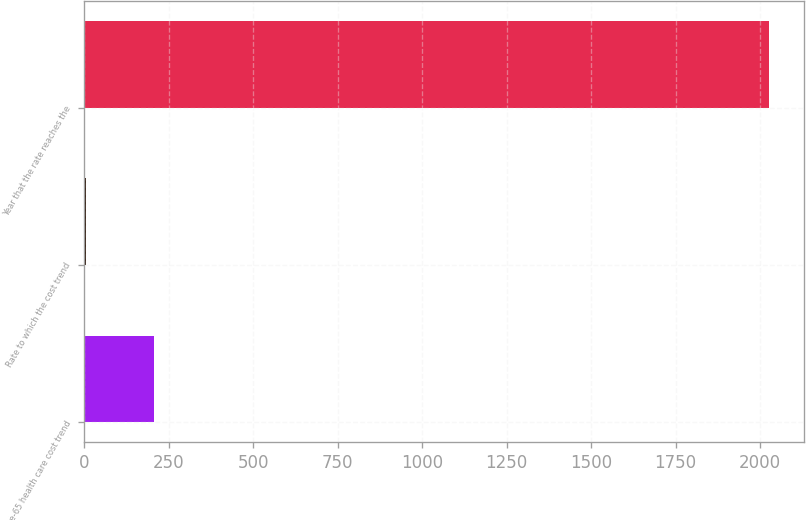Convert chart to OTSL. <chart><loc_0><loc_0><loc_500><loc_500><bar_chart><fcel>Pre-65 health care cost trend<fcel>Rate to which the cost trend<fcel>Year that the rate reaches the<nl><fcel>206.85<fcel>4.5<fcel>2028<nl></chart> 